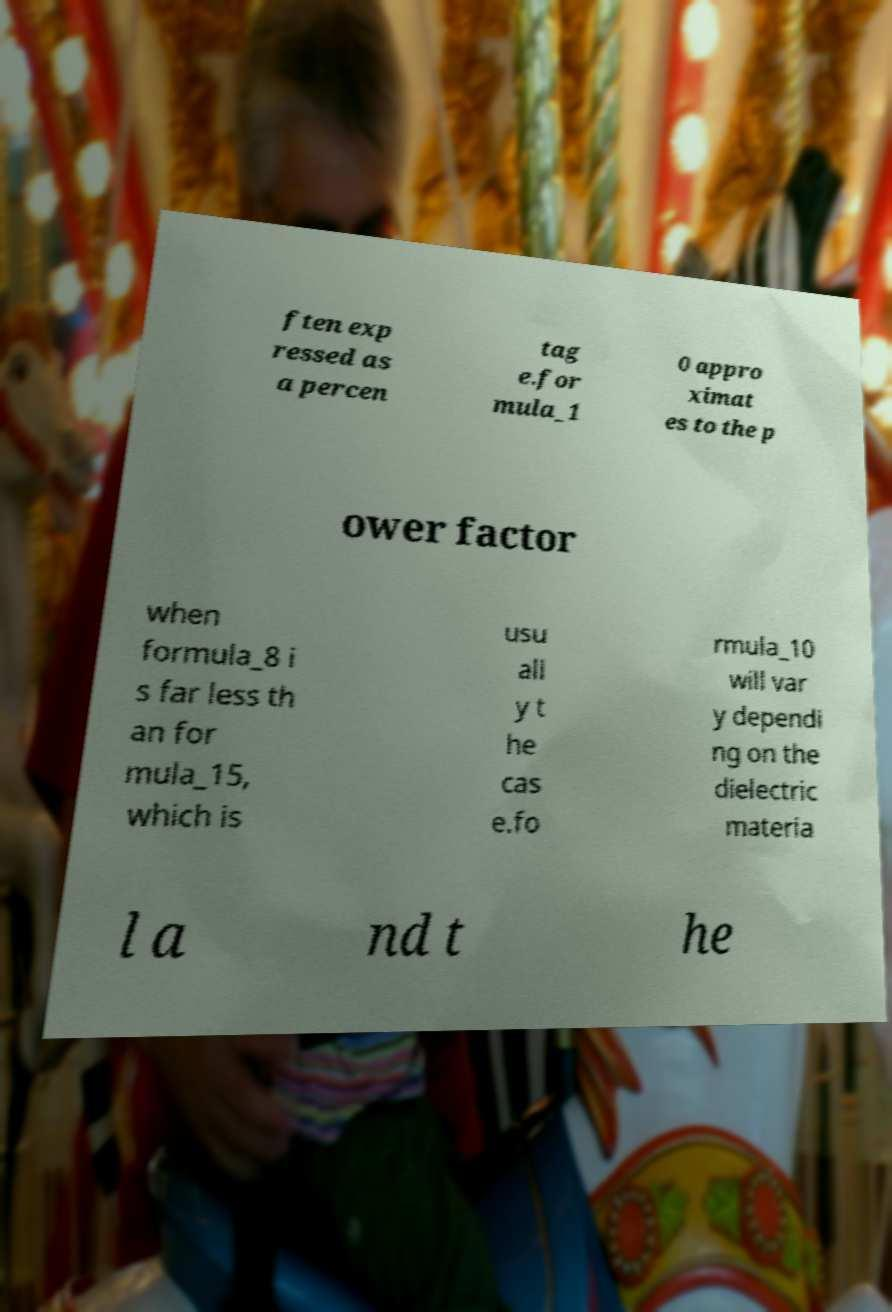For documentation purposes, I need the text within this image transcribed. Could you provide that? ften exp ressed as a percen tag e.for mula_1 0 appro ximat es to the p ower factor when formula_8 i s far less th an for mula_15, which is usu all y t he cas e.fo rmula_10 will var y dependi ng on the dielectric materia l a nd t he 